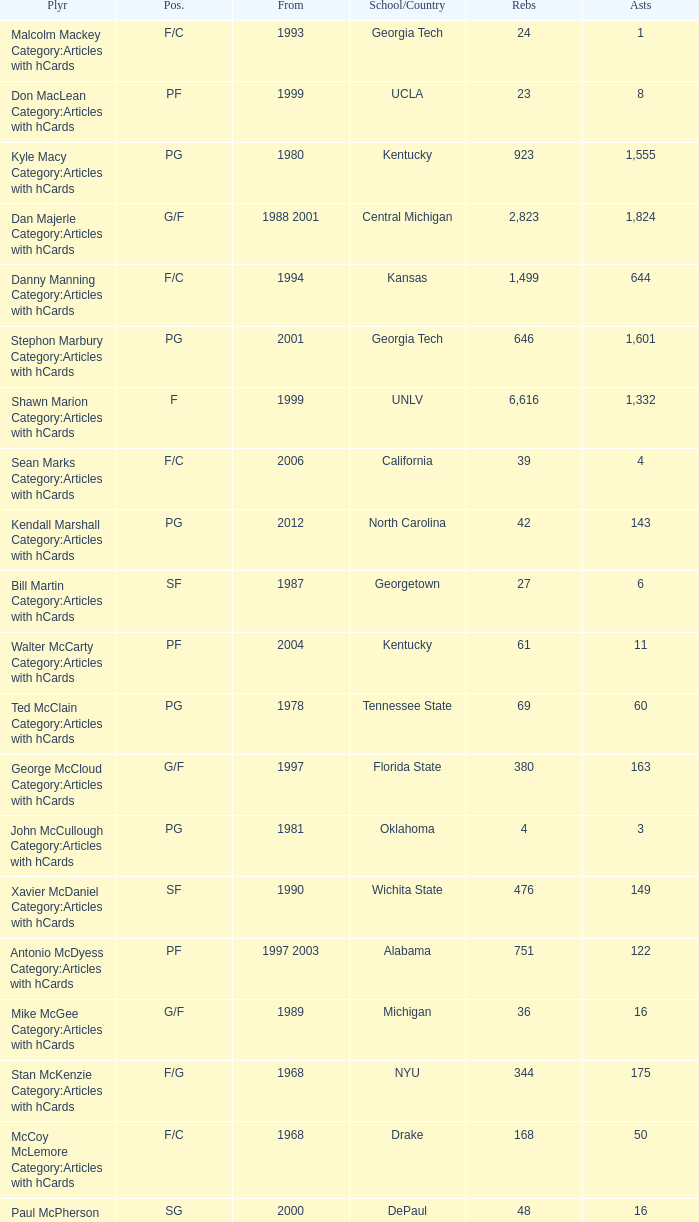What position does the player from arkansas play? C. 